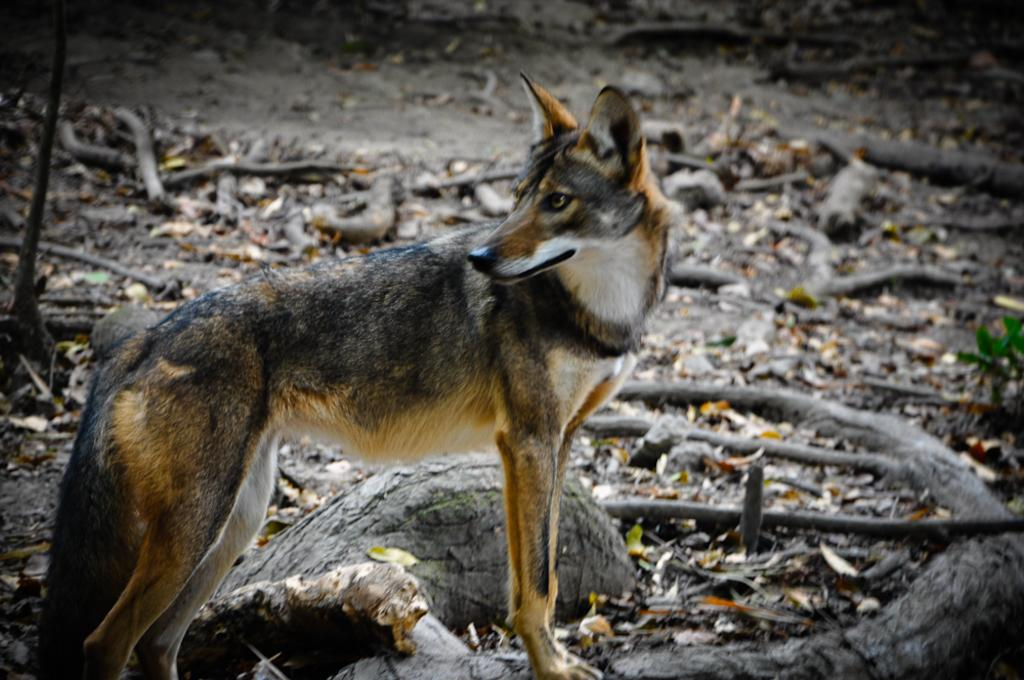What is the main subject in the center of the image? There is an animal in the center of the image. What can be seen in the background of the image? There are logs in the background of the image. What type of brick is being offered by the animal in the image? There is no brick present in the image, and the animal is not offering anything. 